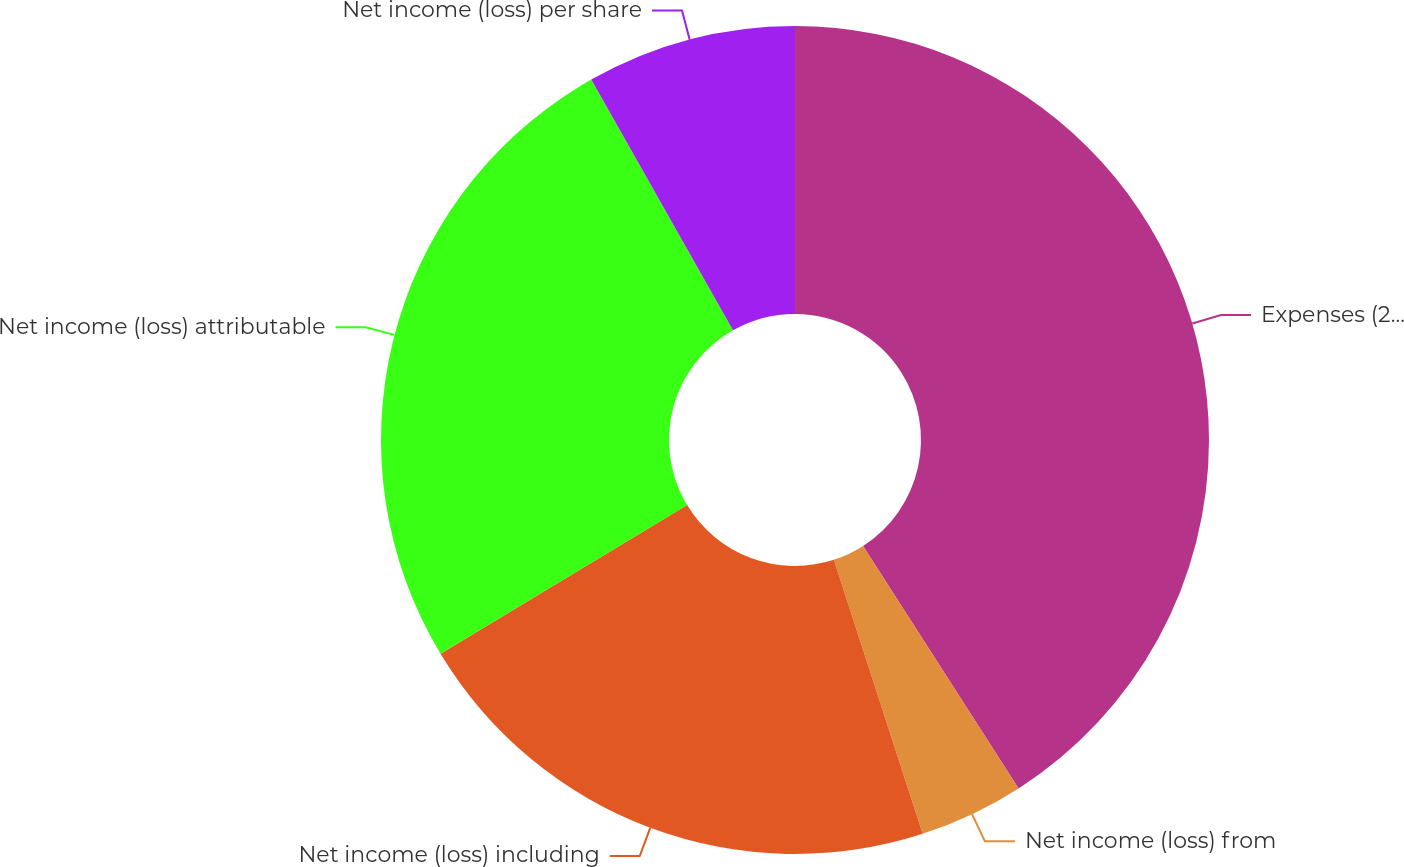<chart> <loc_0><loc_0><loc_500><loc_500><pie_chart><fcel>Expenses (2)(3)<fcel>Net income (loss) from<fcel>Net income (loss) including<fcel>Net income (loss) attributable<fcel>Net income (loss) per share<nl><fcel>40.92%<fcel>4.09%<fcel>21.35%<fcel>25.45%<fcel>8.19%<nl></chart> 